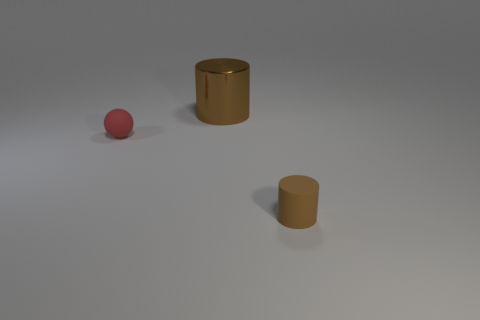Is the size of the rubber cylinder the same as the red ball?
Offer a very short reply. Yes. Are there any big metallic objects in front of the tiny thing that is behind the brown cylinder in front of the red matte ball?
Offer a terse response. No. There is a rubber object that is the same size as the sphere; what is its shape?
Provide a short and direct response. Cylinder. Are there any large cylinders of the same color as the tiny rubber cylinder?
Offer a very short reply. Yes. Does the big thing have the same shape as the small brown object?
Ensure brevity in your answer.  Yes. How many small things are either brown cubes or brown metallic cylinders?
Your answer should be compact. 0. There is a thing that is the same material as the small cylinder; what color is it?
Provide a succinct answer. Red. How many other large brown cylinders are made of the same material as the large brown cylinder?
Make the answer very short. 0. There is a matte object in front of the red object; is its size the same as the cylinder that is behind the small brown cylinder?
Give a very brief answer. No. What material is the cylinder that is left of the cylinder that is in front of the big cylinder?
Your answer should be very brief. Metal. 